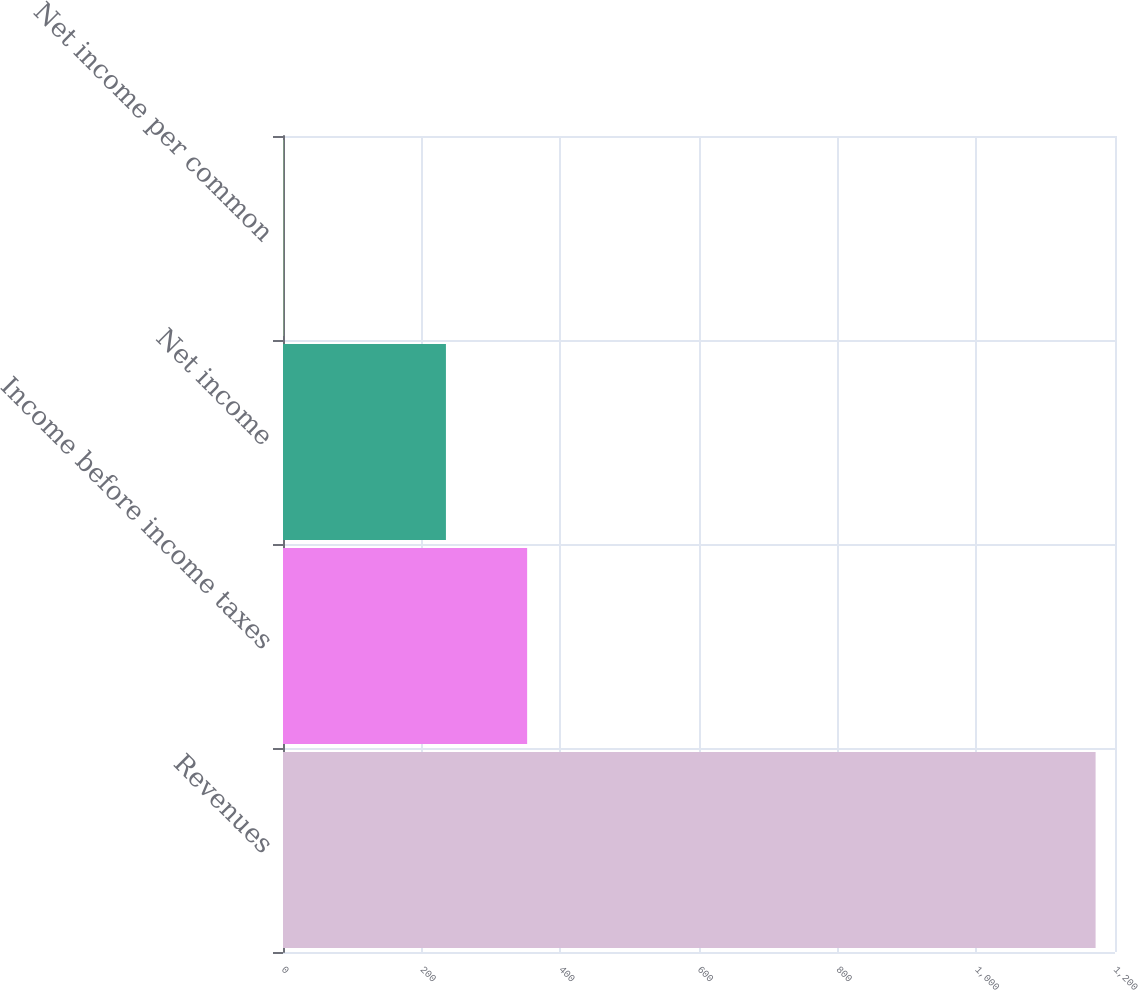Convert chart to OTSL. <chart><loc_0><loc_0><loc_500><loc_500><bar_chart><fcel>Revenues<fcel>Income before income taxes<fcel>Net income<fcel>Net income per common<nl><fcel>1172<fcel>352.13<fcel>235<fcel>0.74<nl></chart> 